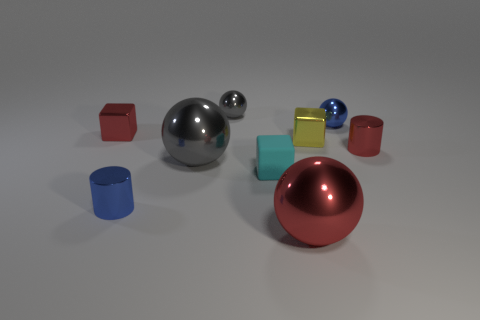Subtract all cylinders. How many objects are left? 7 Subtract 1 gray balls. How many objects are left? 8 Subtract all big red spheres. Subtract all small spheres. How many objects are left? 6 Add 8 small blue metal balls. How many small blue metal balls are left? 9 Add 7 small blue cylinders. How many small blue cylinders exist? 8 